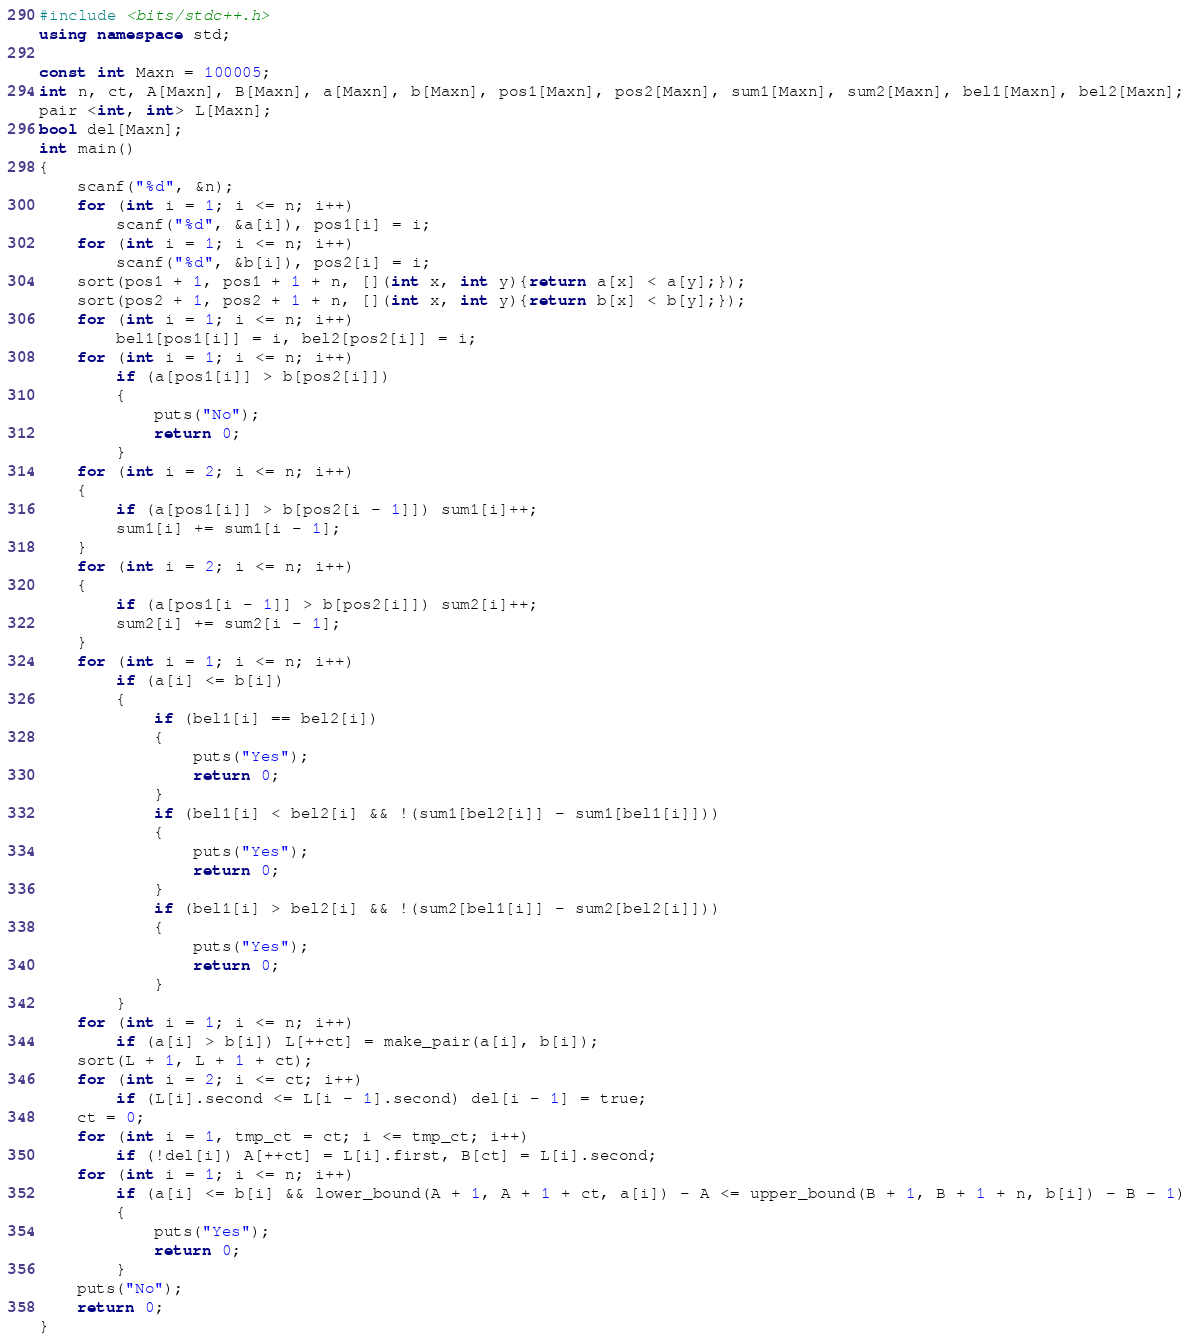<code> <loc_0><loc_0><loc_500><loc_500><_C++_>#include <bits/stdc++.h>
using namespace std;

const int Maxn = 100005;
int n, ct, A[Maxn], B[Maxn], a[Maxn], b[Maxn], pos1[Maxn], pos2[Maxn], sum1[Maxn], sum2[Maxn], bel1[Maxn], bel2[Maxn];
pair <int, int> L[Maxn];
bool del[Maxn];
int main()
{
	scanf("%d", &n);
	for (int i = 1; i <= n; i++)
		scanf("%d", &a[i]), pos1[i] = i;
	for (int i = 1; i <= n; i++)
		scanf("%d", &b[i]), pos2[i] = i;
	sort(pos1 + 1, pos1 + 1 + n, [](int x, int y){return a[x] < a[y];});
	sort(pos2 + 1, pos2 + 1 + n, [](int x, int y){return b[x] < b[y];});
	for (int i = 1; i <= n; i++)
		bel1[pos1[i]] = i, bel2[pos2[i]] = i;
	for (int i = 1; i <= n; i++)
		if (a[pos1[i]] > b[pos2[i]])
		{
			puts("No");
			return 0;
		}
	for (int i = 2; i <= n; i++)
	{
		if (a[pos1[i]] > b[pos2[i - 1]]) sum1[i]++;
		sum1[i] += sum1[i - 1];
	}
	for (int i = 2; i <= n; i++)
	{
		if (a[pos1[i - 1]] > b[pos2[i]]) sum2[i]++;
		sum2[i] += sum2[i - 1];
	}
	for (int i = 1; i <= n; i++)
		if (a[i] <= b[i])
		{
			if (bel1[i] == bel2[i])
			{
				puts("Yes");
				return 0;
			}
			if (bel1[i] < bel2[i] && !(sum1[bel2[i]] - sum1[bel1[i]]))
			{
				puts("Yes");
				return 0;
			}
			if (bel1[i] > bel2[i] && !(sum2[bel1[i]] - sum2[bel2[i]]))
			{
				puts("Yes");
				return 0;
			}
		}
	for (int i = 1; i <= n; i++)
		if (a[i] > b[i]) L[++ct] = make_pair(a[i], b[i]);
	sort(L + 1, L + 1 + ct);
	for (int i = 2; i <= ct; i++)
		if (L[i].second <= L[i - 1].second) del[i - 1] = true;
	ct = 0;
	for (int i = 1, tmp_ct = ct; i <= tmp_ct; i++)
		if (!del[i]) A[++ct] = L[i].first, B[ct] = L[i].second;
	for (int i = 1; i <= n; i++)
		if (a[i] <= b[i] && lower_bound(A + 1, A + 1 + ct, a[i]) - A <= upper_bound(B + 1, B + 1 + n, b[i]) - B - 1)
		{
			puts("Yes");
			return 0;
		}
	puts("No");
	return 0;
}</code> 